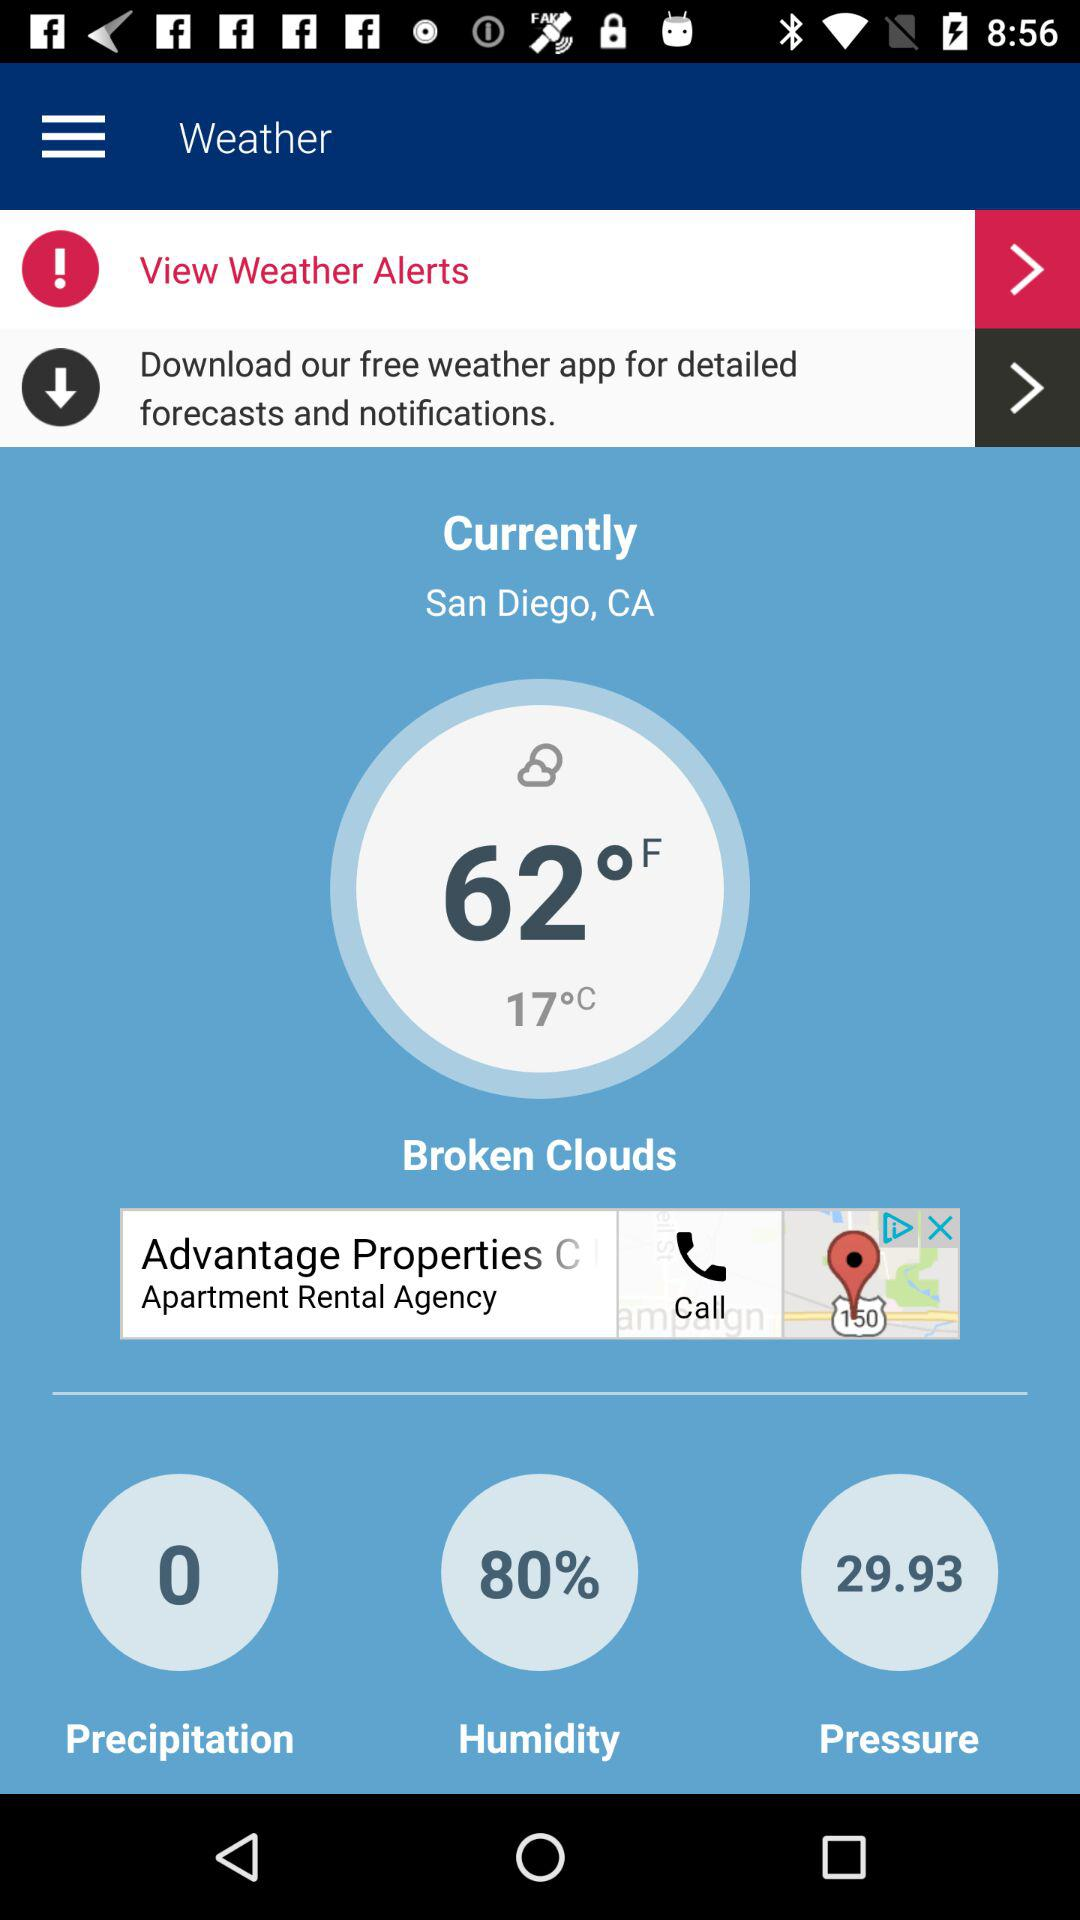How many degrees Celsius is the temperature?
Answer the question using a single word or phrase. 17°C 